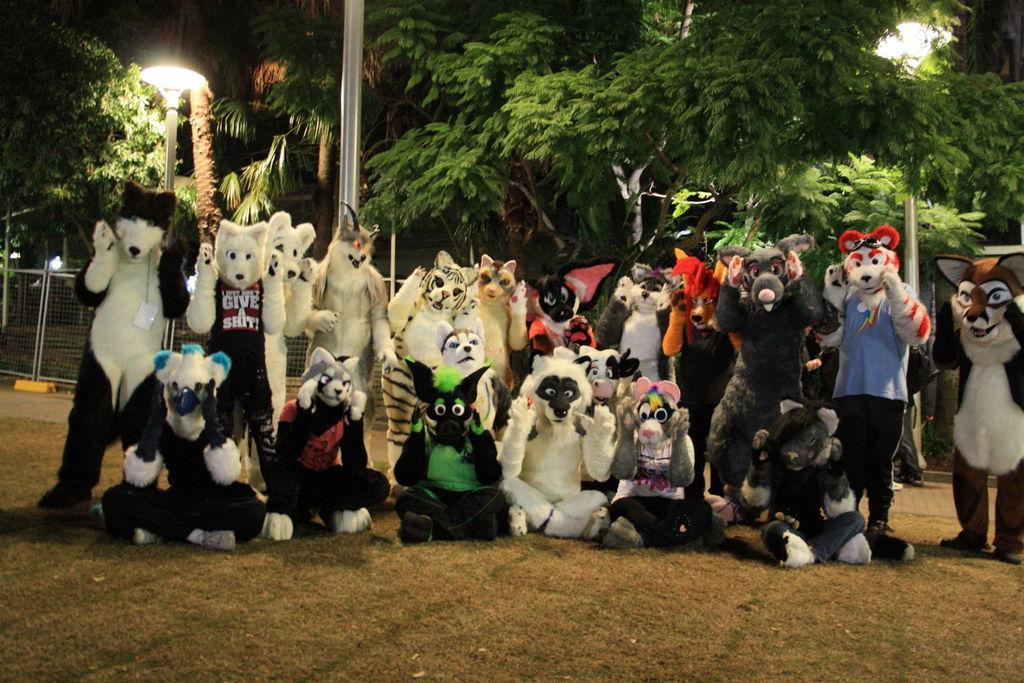Describe this image in one or two sentences. In this picture we can see a group of people wore costumes where some are standing and some are sitting on the ground and in the background we can see poles, lights, trees, fence. 